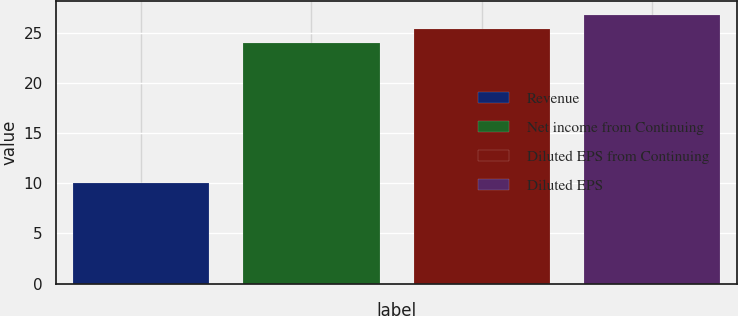Convert chart. <chart><loc_0><loc_0><loc_500><loc_500><bar_chart><fcel>Revenue<fcel>Net income from Continuing<fcel>Diluted EPS from Continuing<fcel>Diluted EPS<nl><fcel>10<fcel>24<fcel>25.4<fcel>26.8<nl></chart> 